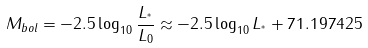Convert formula to latex. <formula><loc_0><loc_0><loc_500><loc_500>M _ { b o l } = - 2 . 5 \log _ { 1 0 } { \frac { L _ { ^ { * } } } { L _ { 0 } } } \approx - 2 . 5 \log _ { 1 0 } L _ { ^ { * } } + 7 1 . 1 9 7 4 2 5</formula> 